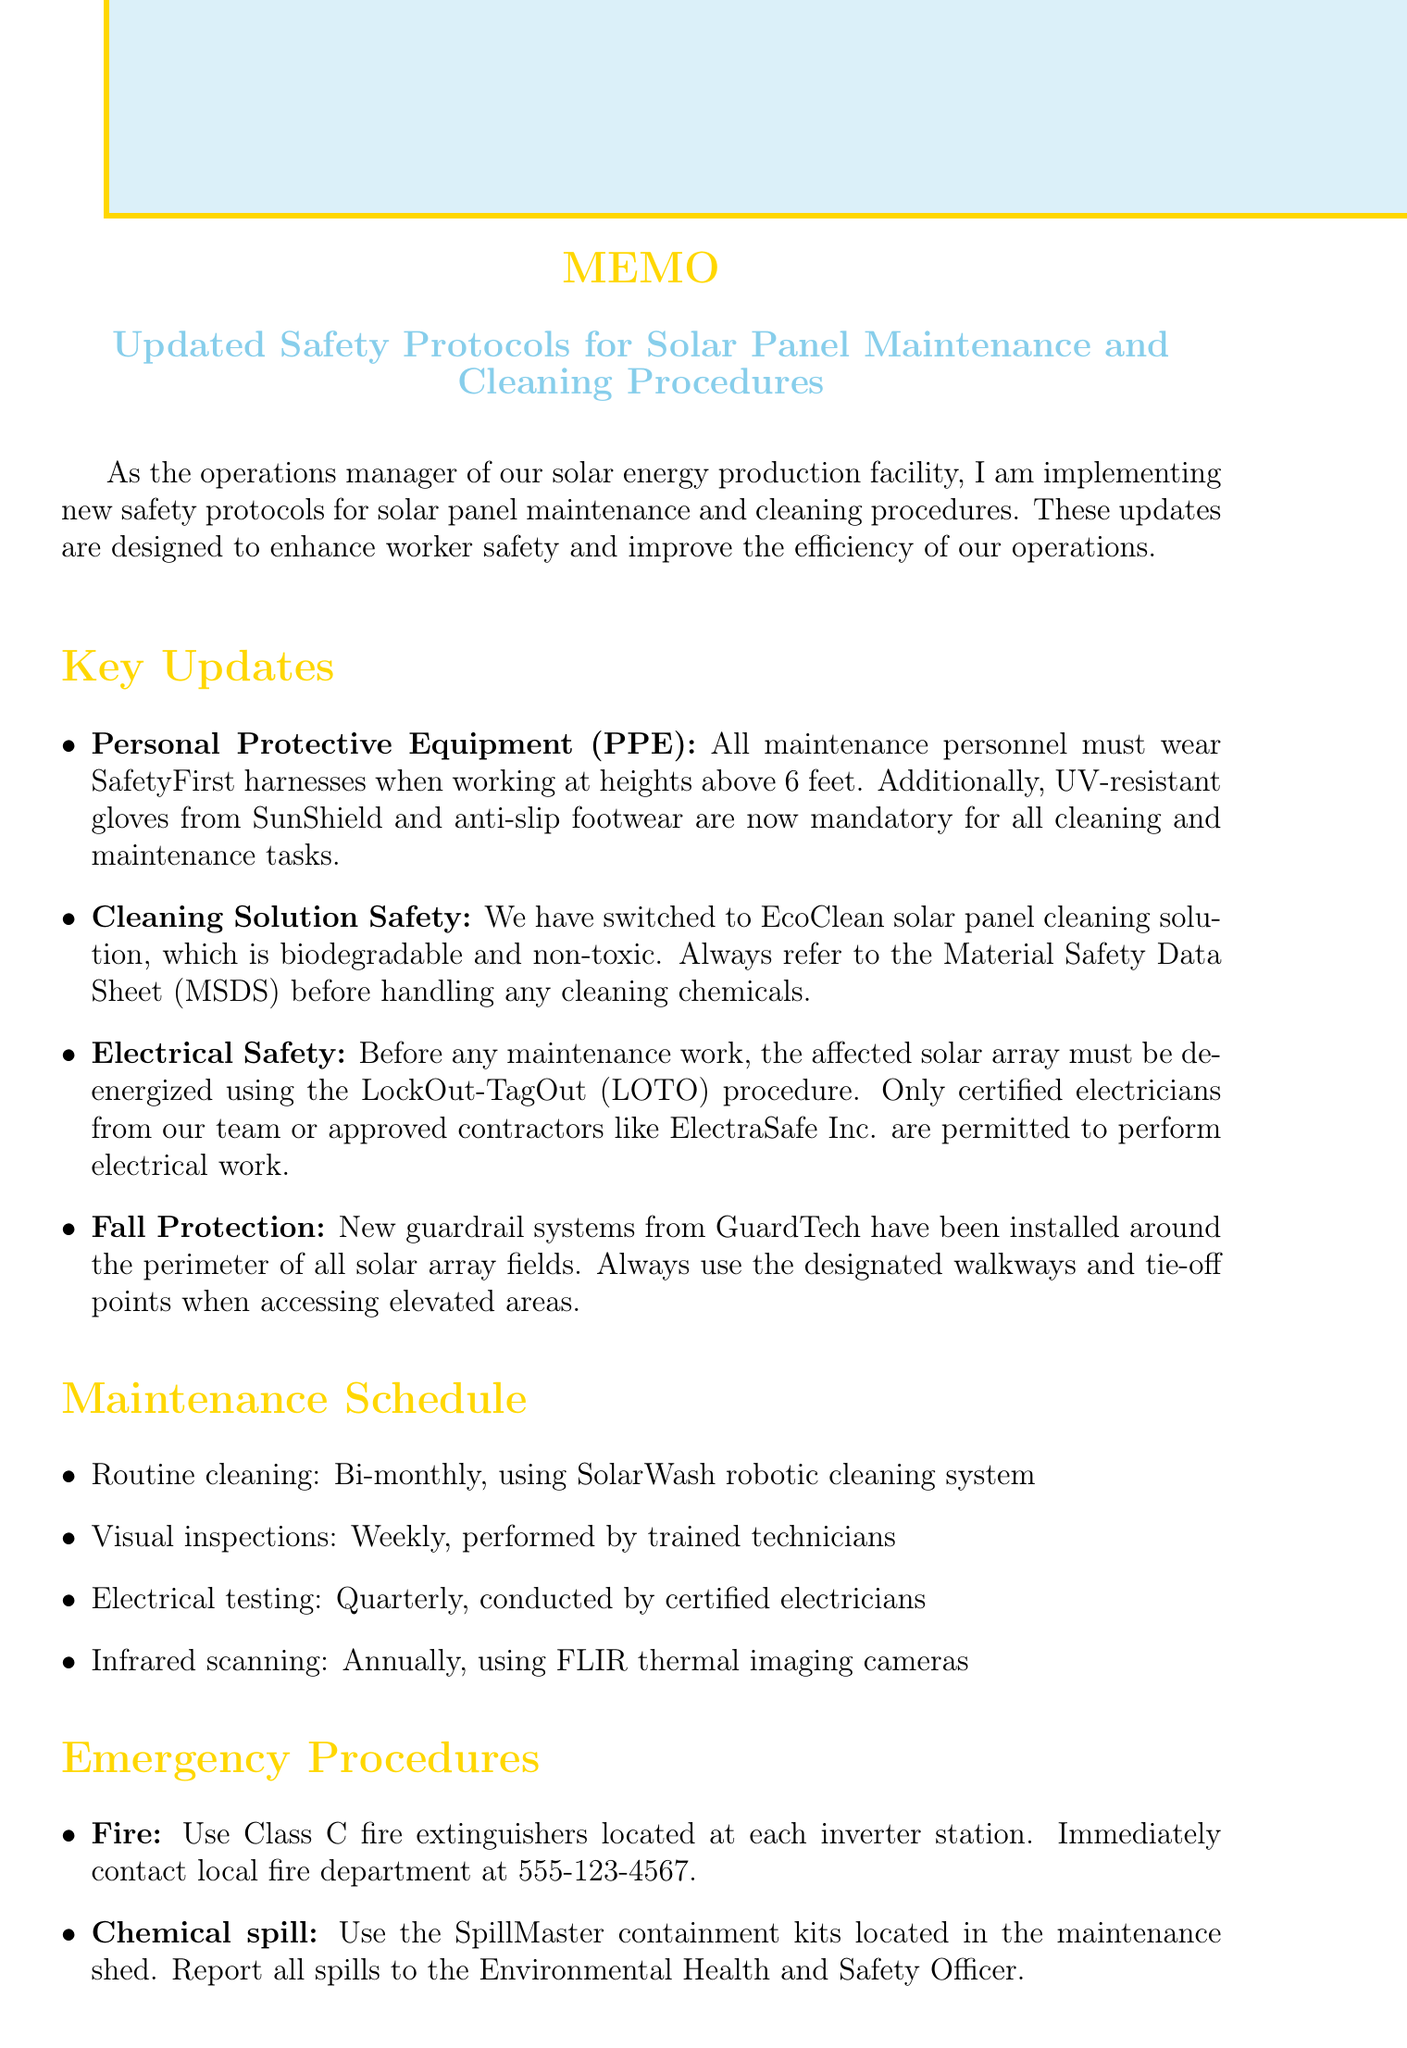What is the title of the memo? The title is stated at the beginning of the document and summarizes the subject matter clearly.
Answer: Updated Safety Protocols for Solar Panel Maintenance and Cleaning Procedures Who must wear SafetyFirst harnesses? This detail is provided in the Personal Protective Equipment section of the document, specifying the required personnel.
Answer: All maintenance personnel What cleaning solution is now being used? The memo mentions the specific product to highlight a change in cleaning procedures.
Answer: EcoClean How often are visual inspections performed? The Maintenance Schedule section includes specific frequencies for various tasks, including visual inspections.
Answer: Weekly Which chemical spill kits should be used? This is outlined under the Emergency Procedures section, detailing the correct equipment used during chemical spills.
Answer: SpillMaster containment kits What certification is required for inverter maintenance personnel? The Training Requirements section specifies certain qualifications needed for specialized tasks.
Answer: Electrical safety certification What is the emergency contact number for fire services? This information is provided within the Emergency Procedures section for quick access during emergencies.
Answer: 555-123-4567 What is the consequence of not signing the attached form? This detail helps understand the importance of compliance with the newly updated protocols.
Answer: Non-compliance with safety protocols 